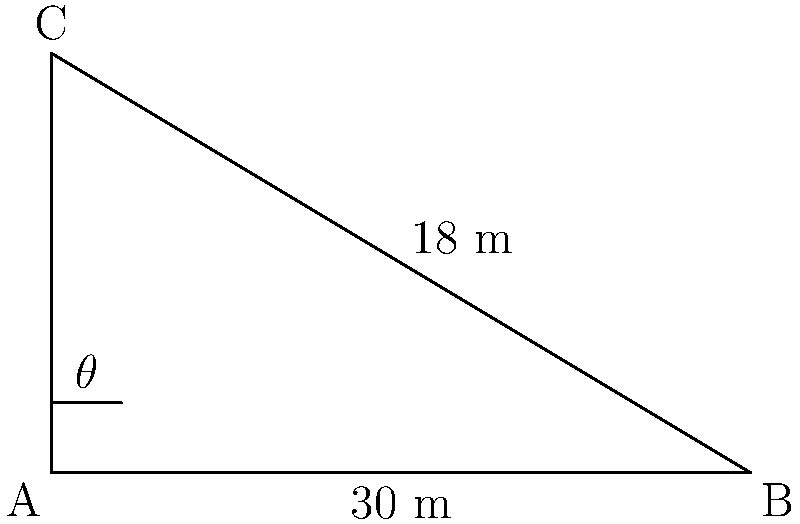During your spiritual journey, you encounter a sacred staircase leading to an ancient temple. The horizontal distance from the base to the top of the staircase is 30 meters, and its vertical rise is 18 meters. What is the angle of inclination ($\theta$) of the staircase? To find the angle of inclination, we can use the tangent function from trigonometry. Here's how:

1) In a right triangle, $\tan \theta = \frac{\text{opposite}}{\text{adjacent}}$

2) In this case:
   - The opposite side is the vertical rise: 18 meters
   - The adjacent side is the horizontal distance: 30 meters

3) So, we can set up the equation:
   $\tan \theta = \frac{18}{30}$

4) Simplify the fraction:
   $\tan \theta = \frac{3}{5}$

5) To find $\theta$, we need to use the inverse tangent function (also called arctangent):
   $\theta = \tan^{-1}(\frac{3}{5})$

6) Using a calculator or trigonometric tables:
   $\theta \approx 30.96^\circ$

7) Rounding to the nearest degree:
   $\theta \approx 31^\circ$
Answer: $31^\circ$ 